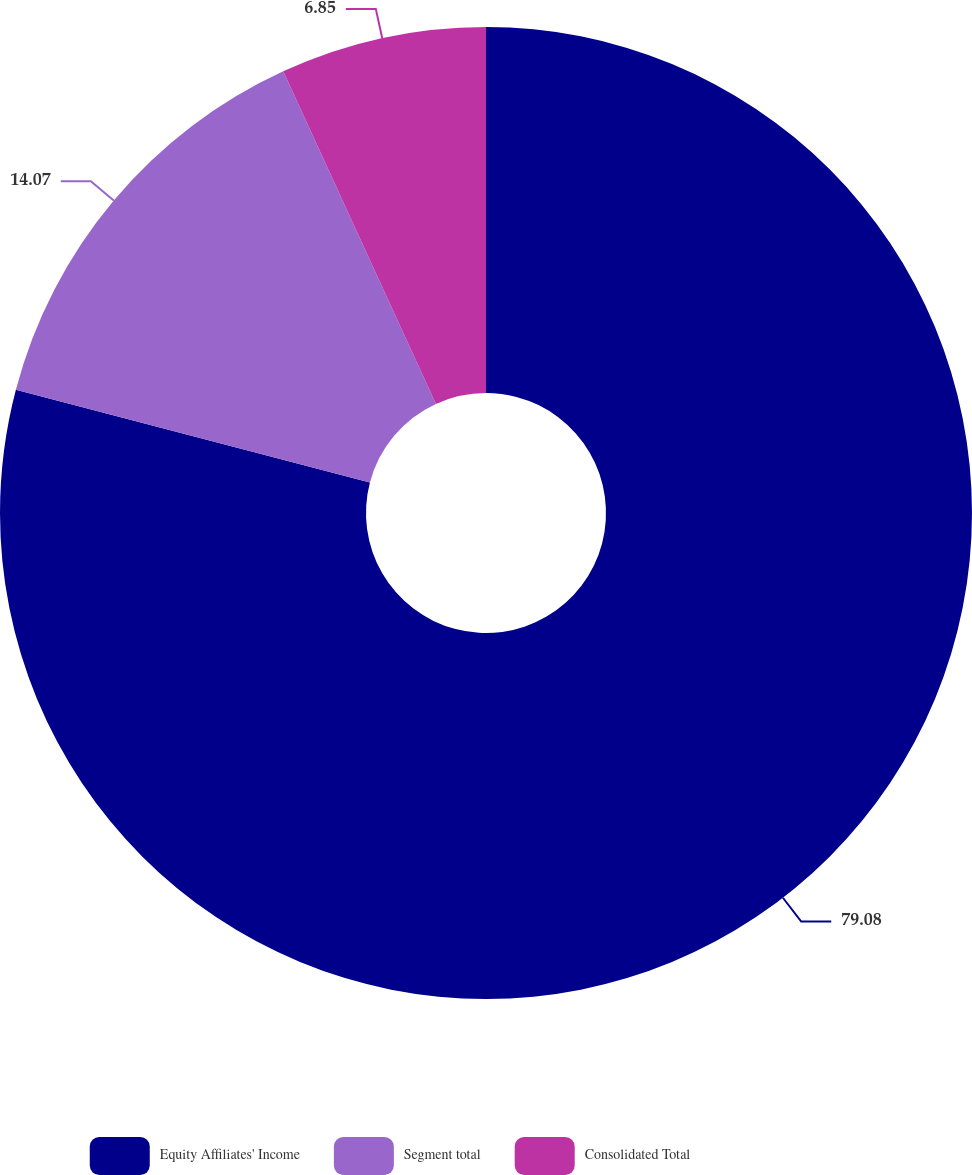Convert chart. <chart><loc_0><loc_0><loc_500><loc_500><pie_chart><fcel>Equity Affiliates' Income<fcel>Segment total<fcel>Consolidated Total<nl><fcel>79.08%<fcel>14.07%<fcel>6.85%<nl></chart> 